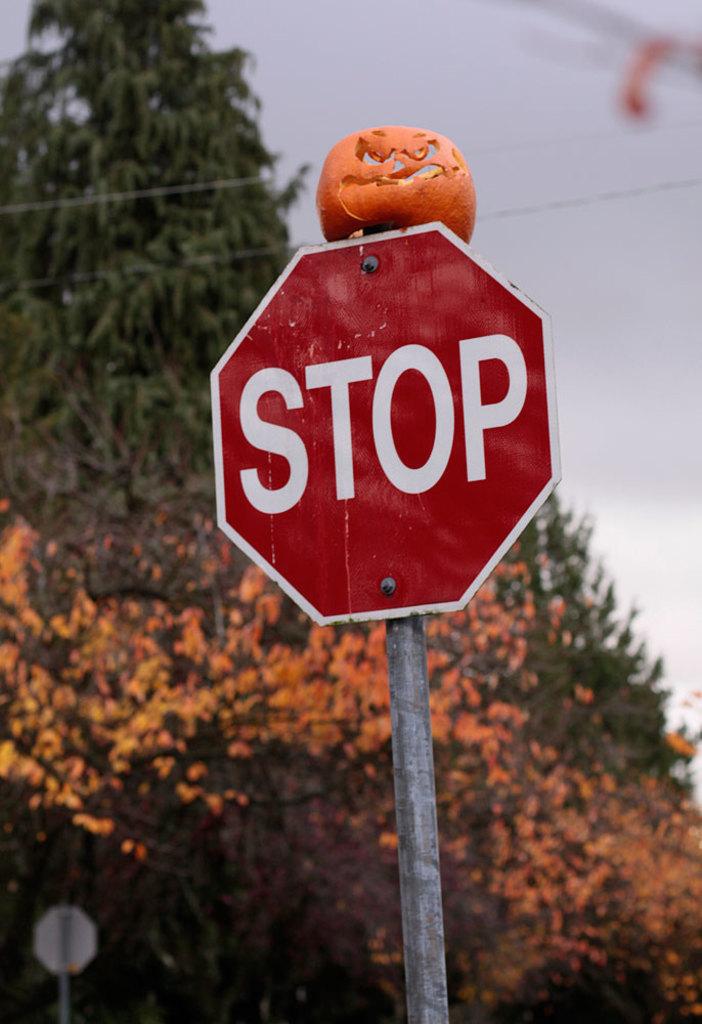What does the sign say?
Provide a succinct answer. Stop. 